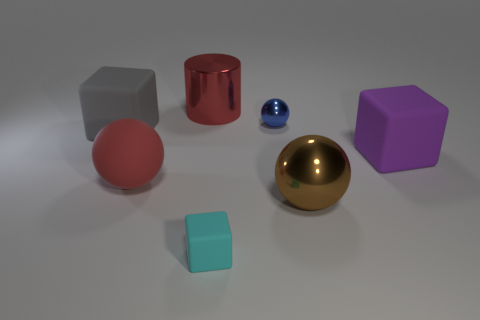There is a large red object that is the same shape as the blue metallic thing; what is it made of?
Your response must be concise. Rubber. There is a shiny thing that is in front of the tiny object behind the big metallic thing in front of the red shiny thing; what size is it?
Keep it short and to the point. Large. Are there any large balls on the left side of the small blue metallic object?
Offer a terse response. Yes. There is a ball that is made of the same material as the blue object; what size is it?
Your answer should be very brief. Large. How many brown metal objects have the same shape as the blue metallic object?
Your response must be concise. 1. Is the material of the brown sphere the same as the big cube left of the blue thing?
Provide a short and direct response. No. Is the number of red matte things that are behind the large brown shiny thing greater than the number of blue cylinders?
Make the answer very short. Yes. What shape is the big shiny thing that is the same color as the rubber sphere?
Your answer should be compact. Cylinder. Is there a small cyan cube made of the same material as the big red ball?
Provide a succinct answer. Yes. Does the sphere that is behind the gray rubber thing have the same material as the object that is in front of the brown ball?
Provide a succinct answer. No. 